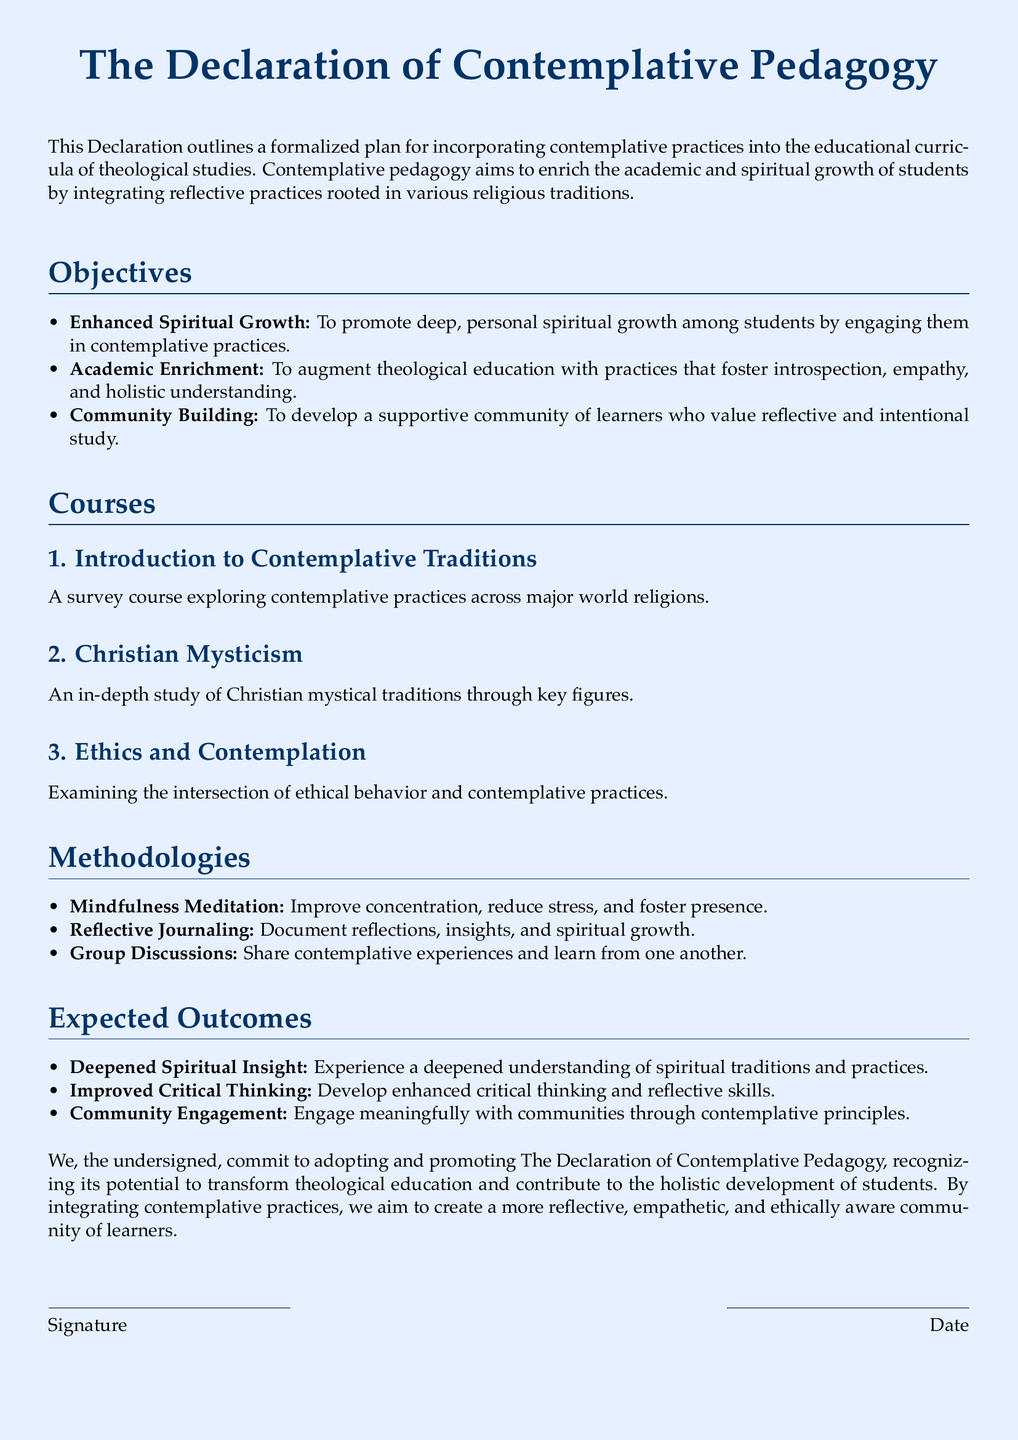What is the title of the document? The title is prominently displayed at the top of the document, clearly stating the subject matter.
Answer: The Declaration of Contemplative Pedagogy What is one objective of the pedagogy? The objectives section lists specific goals for integrating contemplative practices in education, one of which is enhancing spiritual growth.
Answer: Enhanced Spiritual Growth How many courses are listed in the document? The courses section explicitly counts the number of courses offered under contemplative pedagogy.
Answer: Three What methodology involves documenting insights? The methodologies section describes different practices, one being reflective journaling which focuses on documenting insights.
Answer: Reflective Journaling What kind of community does the Declaration aim to develop? The objectives mention the goal of fostering a supportive learning environment among students.
Answer: Supportive community What is an expected outcome related to critical thinking? The expected outcomes outline specific results of the program, highlighting improved critical thinking as a key benefit.
Answer: Improved Critical Thinking Who is committing to the adoption of this Declaration? The closing section notes that the undersigned commit to adopting the principles outlined in the document.
Answer: The undersigned What is the date area meant for? The signature lines indicate that individuals can sign and date the document to signify their commitment.
Answer: Signature and Date 